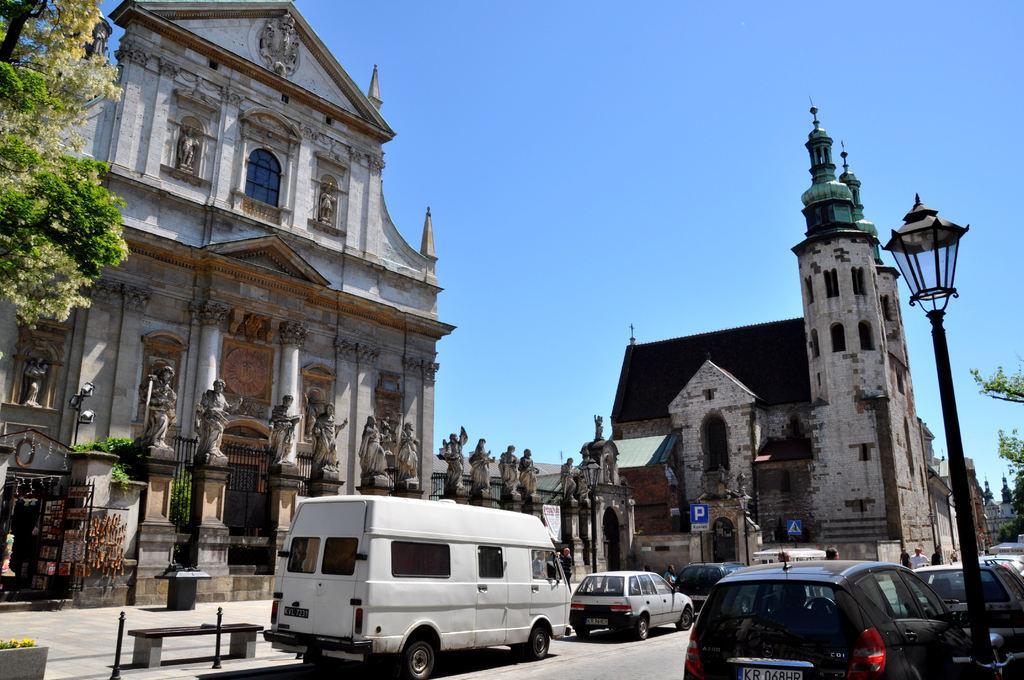Could you give a brief overview of what you see in this image? In this image I can see road and on it I can see number of vehicles. I can also see few poles, a street light, few blue colour sign boards, trees, buildings and sky. I can also see number of sculptures over here. Here I can see a bench. 